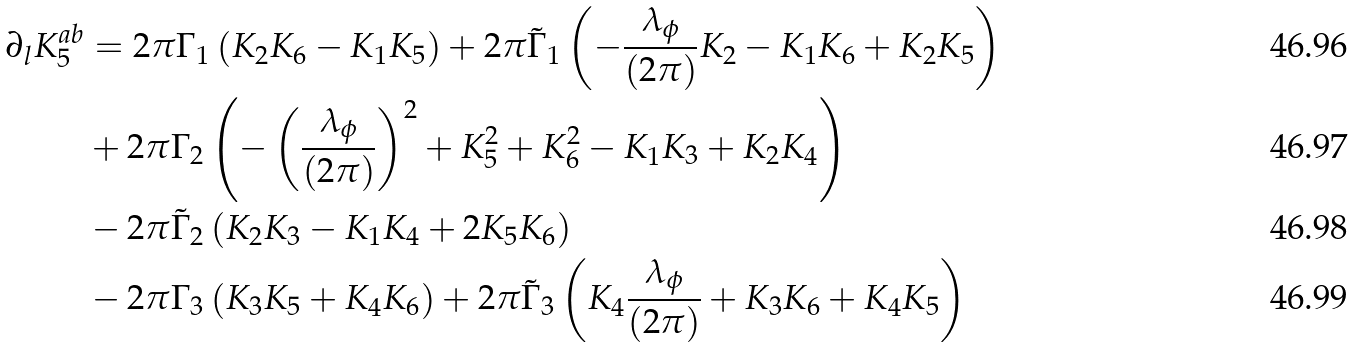<formula> <loc_0><loc_0><loc_500><loc_500>\partial _ { l } K _ { 5 } ^ { a b } & = 2 \pi \Gamma _ { 1 } \left ( K _ { 2 } K _ { 6 } - K _ { 1 } K _ { 5 } \right ) + 2 \pi \tilde { \Gamma } _ { 1 } \left ( - \frac { \lambda _ { \phi } } { ( 2 \pi ) } K _ { 2 } - K _ { 1 } K _ { 6 } + K _ { 2 } K _ { 5 } \right ) \\ & + 2 \pi \Gamma _ { 2 } \left ( - \left ( \frac { \lambda _ { \phi } } { ( 2 \pi ) } \right ) ^ { 2 } + K _ { 5 } ^ { 2 } + K _ { 6 } ^ { 2 } - K _ { 1 } K _ { 3 } + K _ { 2 } K _ { 4 } \right ) \\ & - 2 \pi \tilde { \Gamma } _ { 2 } \left ( K _ { 2 } K _ { 3 } - K _ { 1 } K _ { 4 } + 2 K _ { 5 } K _ { 6 } \right ) \\ & - 2 \pi \Gamma _ { 3 } \left ( K _ { 3 } K _ { 5 } + K _ { 4 } K _ { 6 } \right ) + 2 \pi \tilde { \Gamma } _ { 3 } \left ( K _ { 4 } \frac { \lambda _ { \phi } } { ( 2 \pi ) } + K _ { 3 } K _ { 6 } + K _ { 4 } K _ { 5 } \right )</formula> 